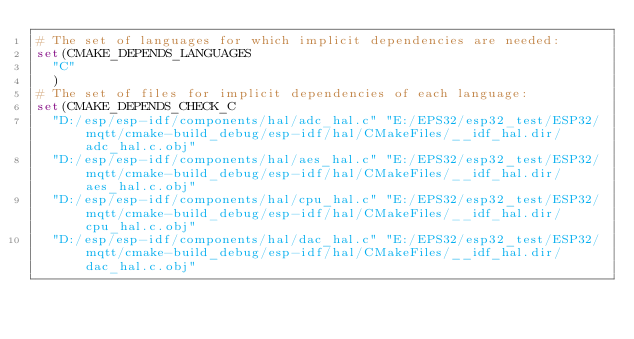<code> <loc_0><loc_0><loc_500><loc_500><_CMake_># The set of languages for which implicit dependencies are needed:
set(CMAKE_DEPENDS_LANGUAGES
  "C"
  )
# The set of files for implicit dependencies of each language:
set(CMAKE_DEPENDS_CHECK_C
  "D:/esp/esp-idf/components/hal/adc_hal.c" "E:/EPS32/esp32_test/ESP32/mqtt/cmake-build_debug/esp-idf/hal/CMakeFiles/__idf_hal.dir/adc_hal.c.obj"
  "D:/esp/esp-idf/components/hal/aes_hal.c" "E:/EPS32/esp32_test/ESP32/mqtt/cmake-build_debug/esp-idf/hal/CMakeFiles/__idf_hal.dir/aes_hal.c.obj"
  "D:/esp/esp-idf/components/hal/cpu_hal.c" "E:/EPS32/esp32_test/ESP32/mqtt/cmake-build_debug/esp-idf/hal/CMakeFiles/__idf_hal.dir/cpu_hal.c.obj"
  "D:/esp/esp-idf/components/hal/dac_hal.c" "E:/EPS32/esp32_test/ESP32/mqtt/cmake-build_debug/esp-idf/hal/CMakeFiles/__idf_hal.dir/dac_hal.c.obj"</code> 